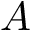Convert formula to latex. <formula><loc_0><loc_0><loc_500><loc_500>A</formula> 